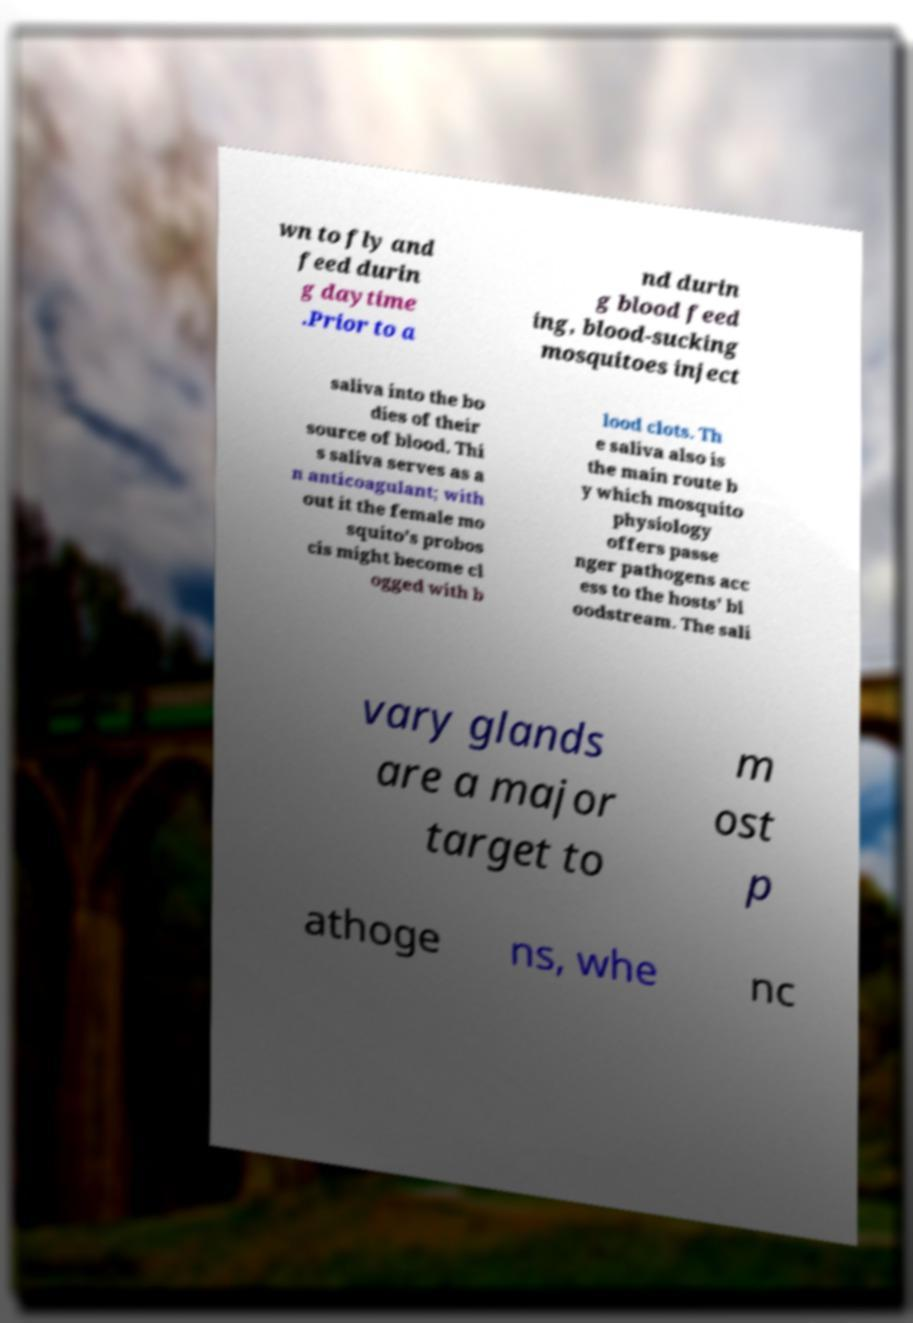Can you accurately transcribe the text from the provided image for me? wn to fly and feed durin g daytime .Prior to a nd durin g blood feed ing, blood-sucking mosquitoes inject saliva into the bo dies of their source of blood. Thi s saliva serves as a n anticoagulant; with out it the female mo squito's probos cis might become cl ogged with b lood clots. Th e saliva also is the main route b y which mosquito physiology offers passe nger pathogens acc ess to the hosts' bl oodstream. The sali vary glands are a major target to m ost p athoge ns, whe nc 